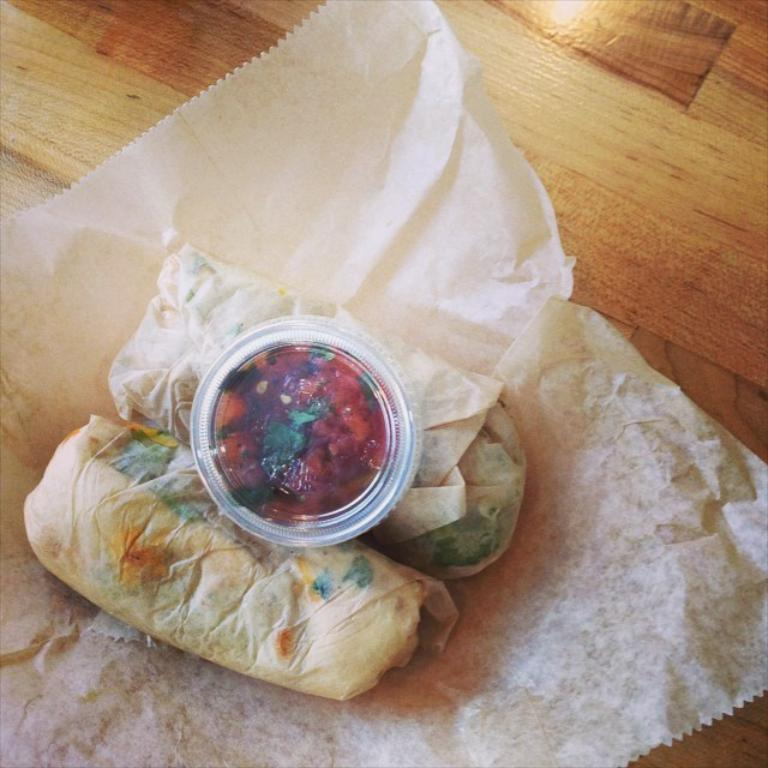What type of items can be seen on the table in the image? There are papers, a box, and food items on the table in the image. Can you describe the box in the image? The box is one of the items placed on the table. What might be the purpose of the papers in the image? The papers could be used for writing, reading, or other purposes. What type of food items are visible in the image? The food items in the image are not specified, but they are present on the table. What degree does the person in the image have? There is no person present in the image, so it is not possible to determine their degree. 